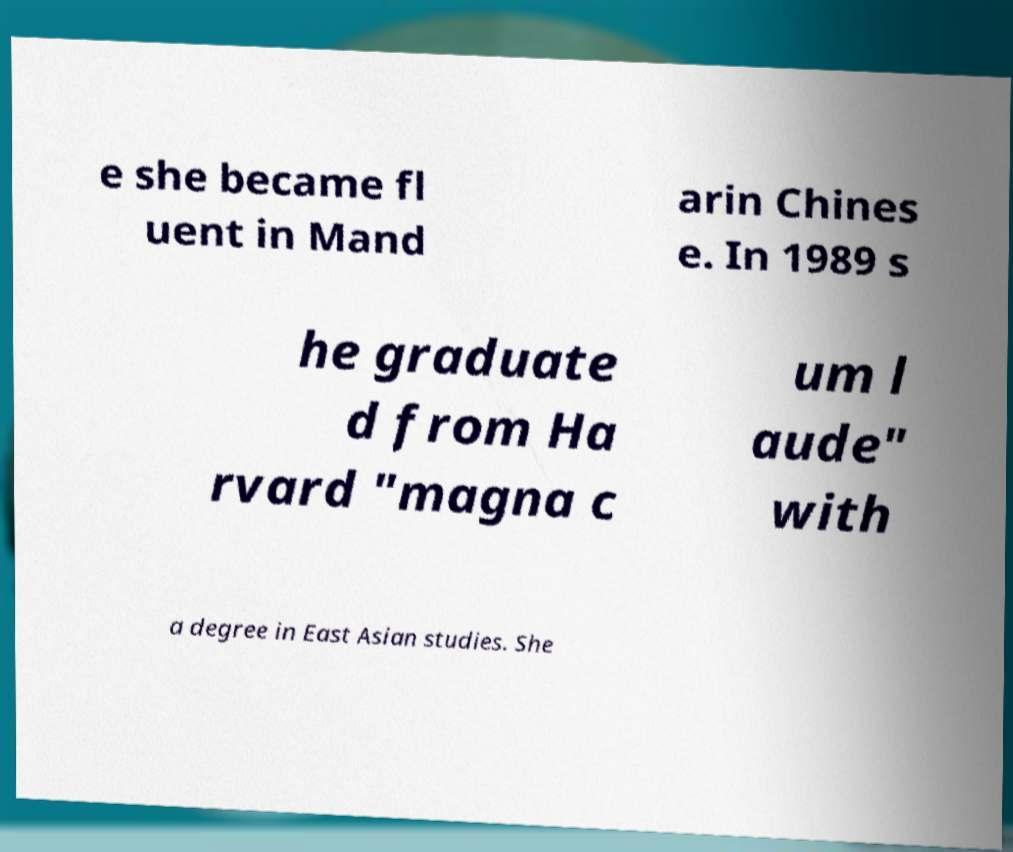There's text embedded in this image that I need extracted. Can you transcribe it verbatim? e she became fl uent in Mand arin Chines e. In 1989 s he graduate d from Ha rvard "magna c um l aude" with a degree in East Asian studies. She 